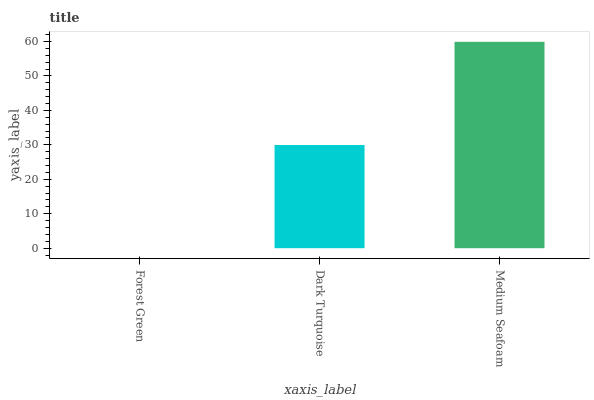Is Forest Green the minimum?
Answer yes or no. Yes. Is Medium Seafoam the maximum?
Answer yes or no. Yes. Is Dark Turquoise the minimum?
Answer yes or no. No. Is Dark Turquoise the maximum?
Answer yes or no. No. Is Dark Turquoise greater than Forest Green?
Answer yes or no. Yes. Is Forest Green less than Dark Turquoise?
Answer yes or no. Yes. Is Forest Green greater than Dark Turquoise?
Answer yes or no. No. Is Dark Turquoise less than Forest Green?
Answer yes or no. No. Is Dark Turquoise the high median?
Answer yes or no. Yes. Is Dark Turquoise the low median?
Answer yes or no. Yes. Is Forest Green the high median?
Answer yes or no. No. Is Forest Green the low median?
Answer yes or no. No. 